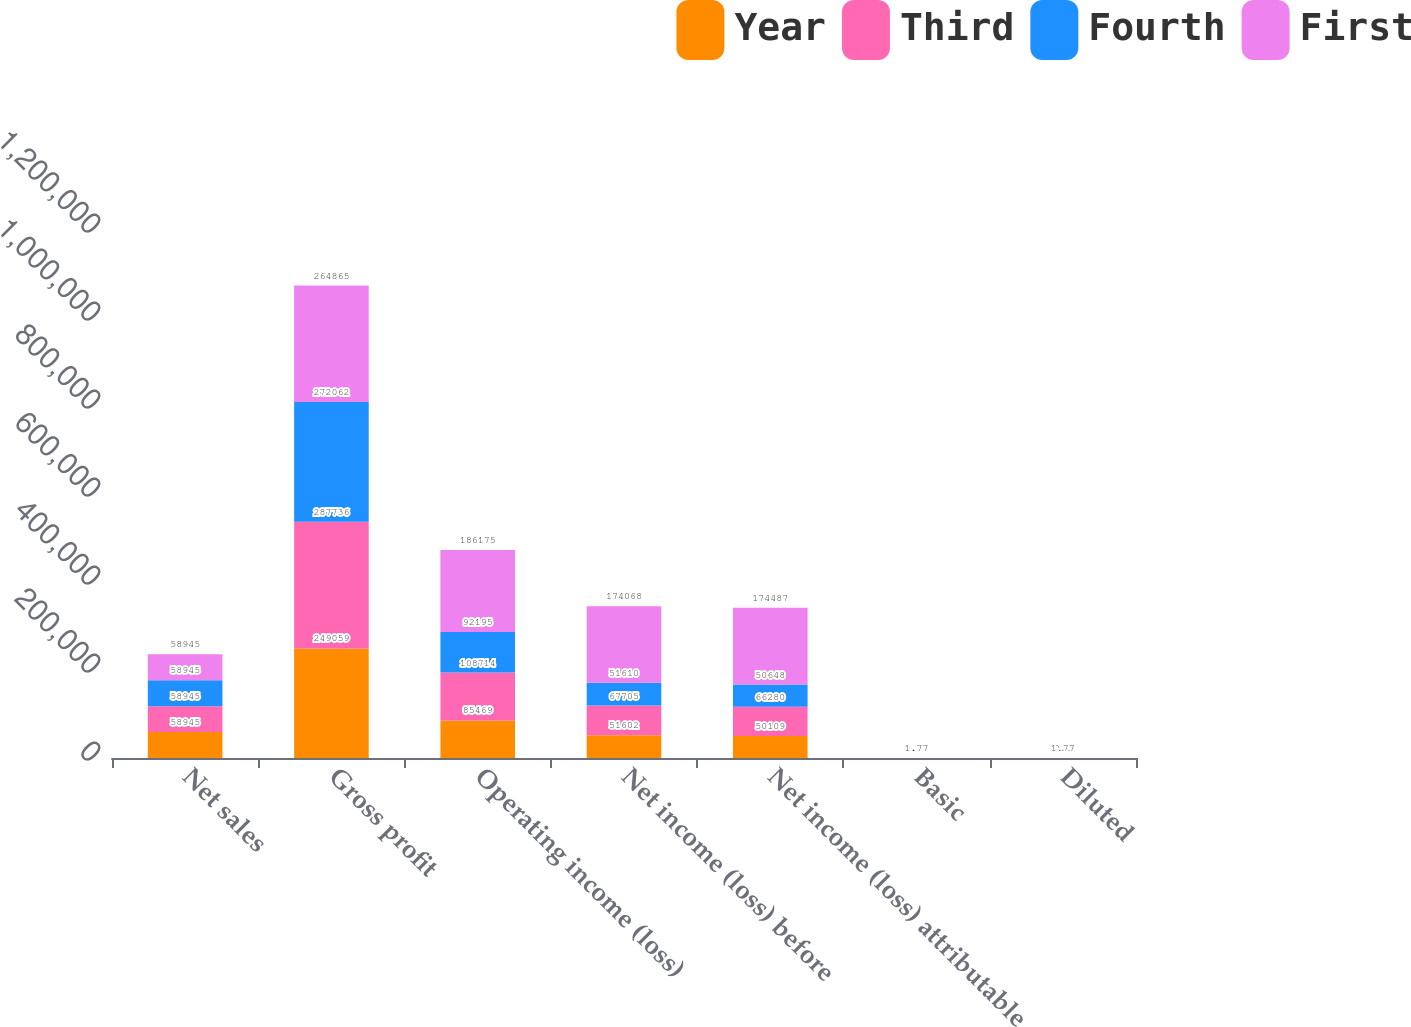<chart> <loc_0><loc_0><loc_500><loc_500><stacked_bar_chart><ecel><fcel>Net sales<fcel>Gross profit<fcel>Operating income (loss)<fcel>Net income (loss) before<fcel>Net income (loss) attributable<fcel>Basic<fcel>Diluted<nl><fcel>Year<fcel>58945<fcel>249059<fcel>85469<fcel>51602<fcel>50109<fcel>0.51<fcel>0.5<nl><fcel>Third<fcel>58945<fcel>287736<fcel>108714<fcel>67705<fcel>66280<fcel>0.67<fcel>0.66<nl><fcel>Fourth<fcel>58945<fcel>272062<fcel>92195<fcel>51610<fcel>50648<fcel>0.51<fcel>0.5<nl><fcel>First<fcel>58945<fcel>264865<fcel>186175<fcel>174068<fcel>174487<fcel>1.77<fcel>1.77<nl></chart> 